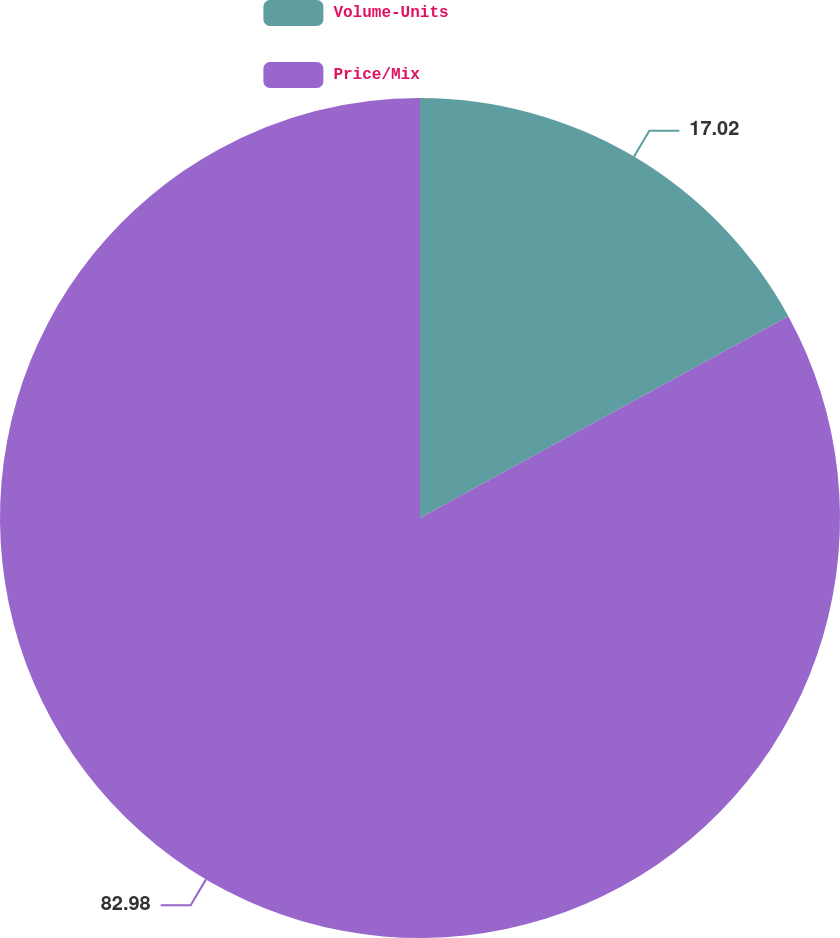Convert chart to OTSL. <chart><loc_0><loc_0><loc_500><loc_500><pie_chart><fcel>Volume-Units<fcel>Price/Mix<nl><fcel>17.02%<fcel>82.98%<nl></chart> 